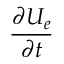Convert formula to latex. <formula><loc_0><loc_0><loc_500><loc_500>\frac { \partial U _ { e } } { \partial t }</formula> 